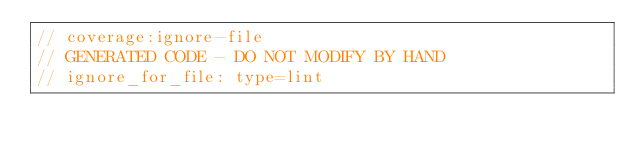<code> <loc_0><loc_0><loc_500><loc_500><_Dart_>// coverage:ignore-file
// GENERATED CODE - DO NOT MODIFY BY HAND
// ignore_for_file: type=lint</code> 